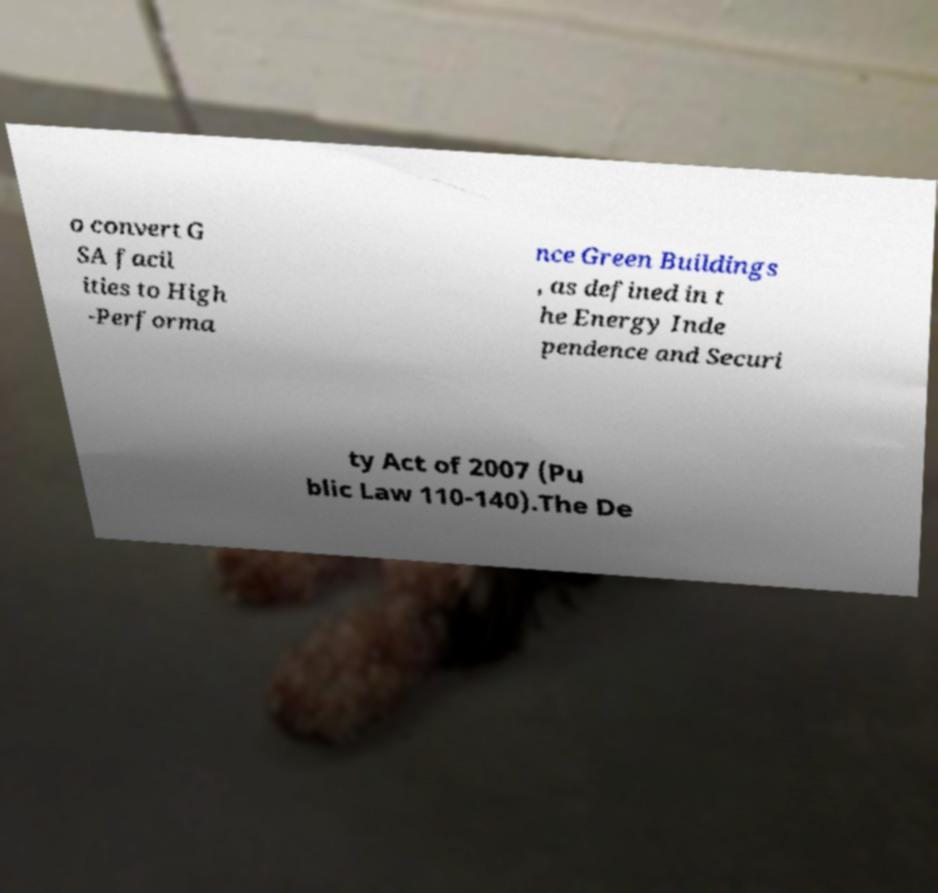There's text embedded in this image that I need extracted. Can you transcribe it verbatim? o convert G SA facil ities to High -Performa nce Green Buildings , as defined in t he Energy Inde pendence and Securi ty Act of 2007 (Pu blic Law 110-140).The De 